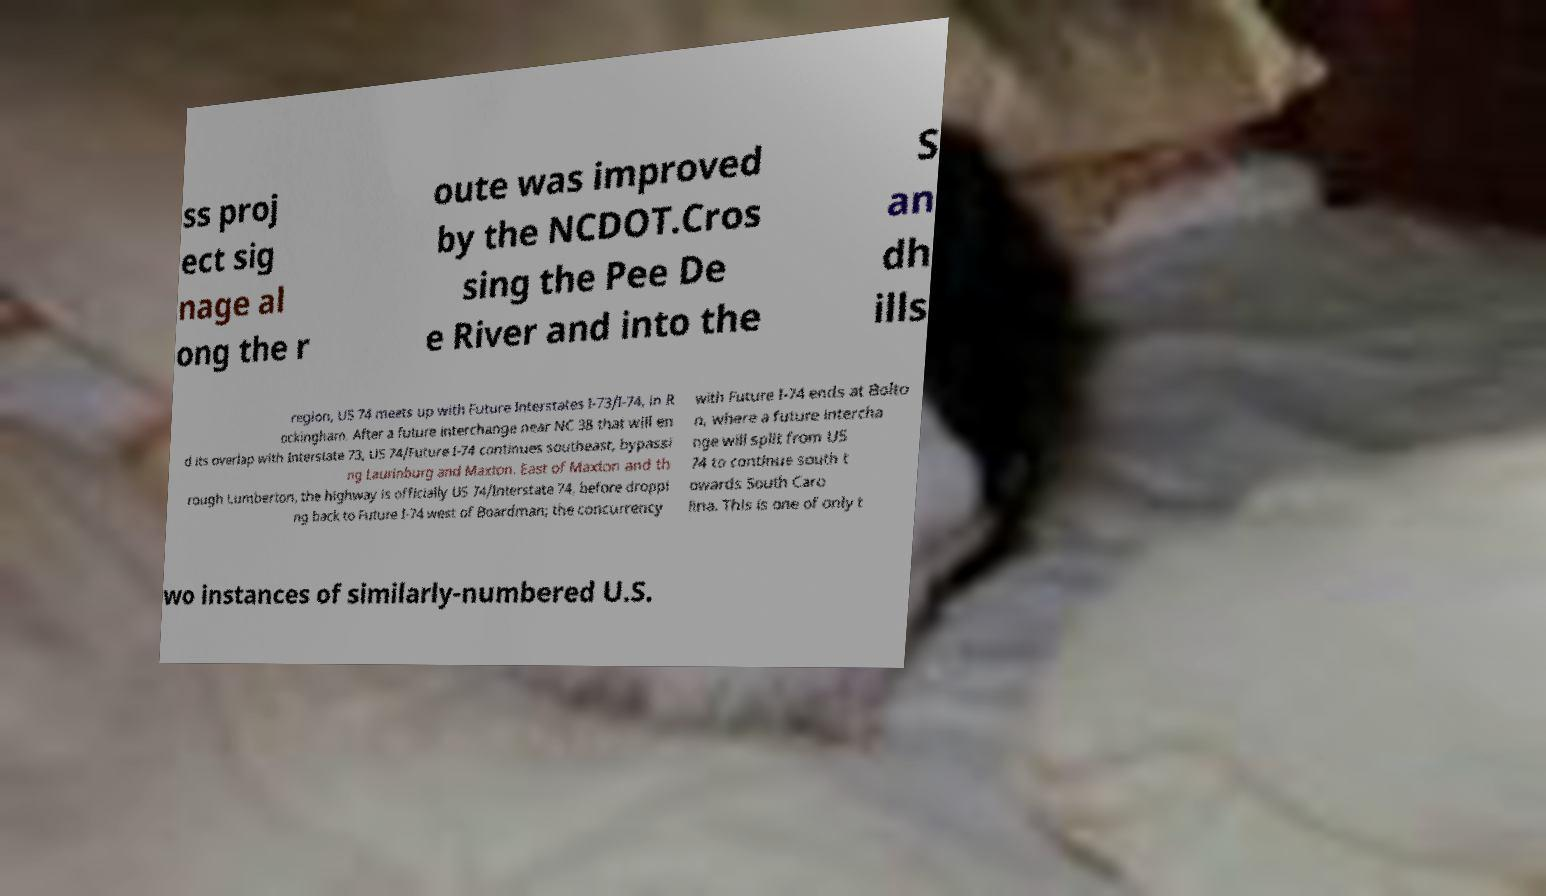Could you assist in decoding the text presented in this image and type it out clearly? ss proj ect sig nage al ong the r oute was improved by the NCDOT.Cros sing the Pee De e River and into the S an dh ills region, US 74 meets up with Future Interstates I-73/I-74, in R ockingham. After a future interchange near NC 38 that will en d its overlap with Interstate 73, US 74/Future I-74 continues southeast, bypassi ng Laurinburg and Maxton. East of Maxton and th rough Lumberton, the highway is officially US 74/Interstate 74, before droppi ng back to Future I-74 west of Boardman; the concurrency with Future I-74 ends at Bolto n, where a future intercha nge will split from US 74 to continue south t owards South Caro lina. This is one of only t wo instances of similarly-numbered U.S. 